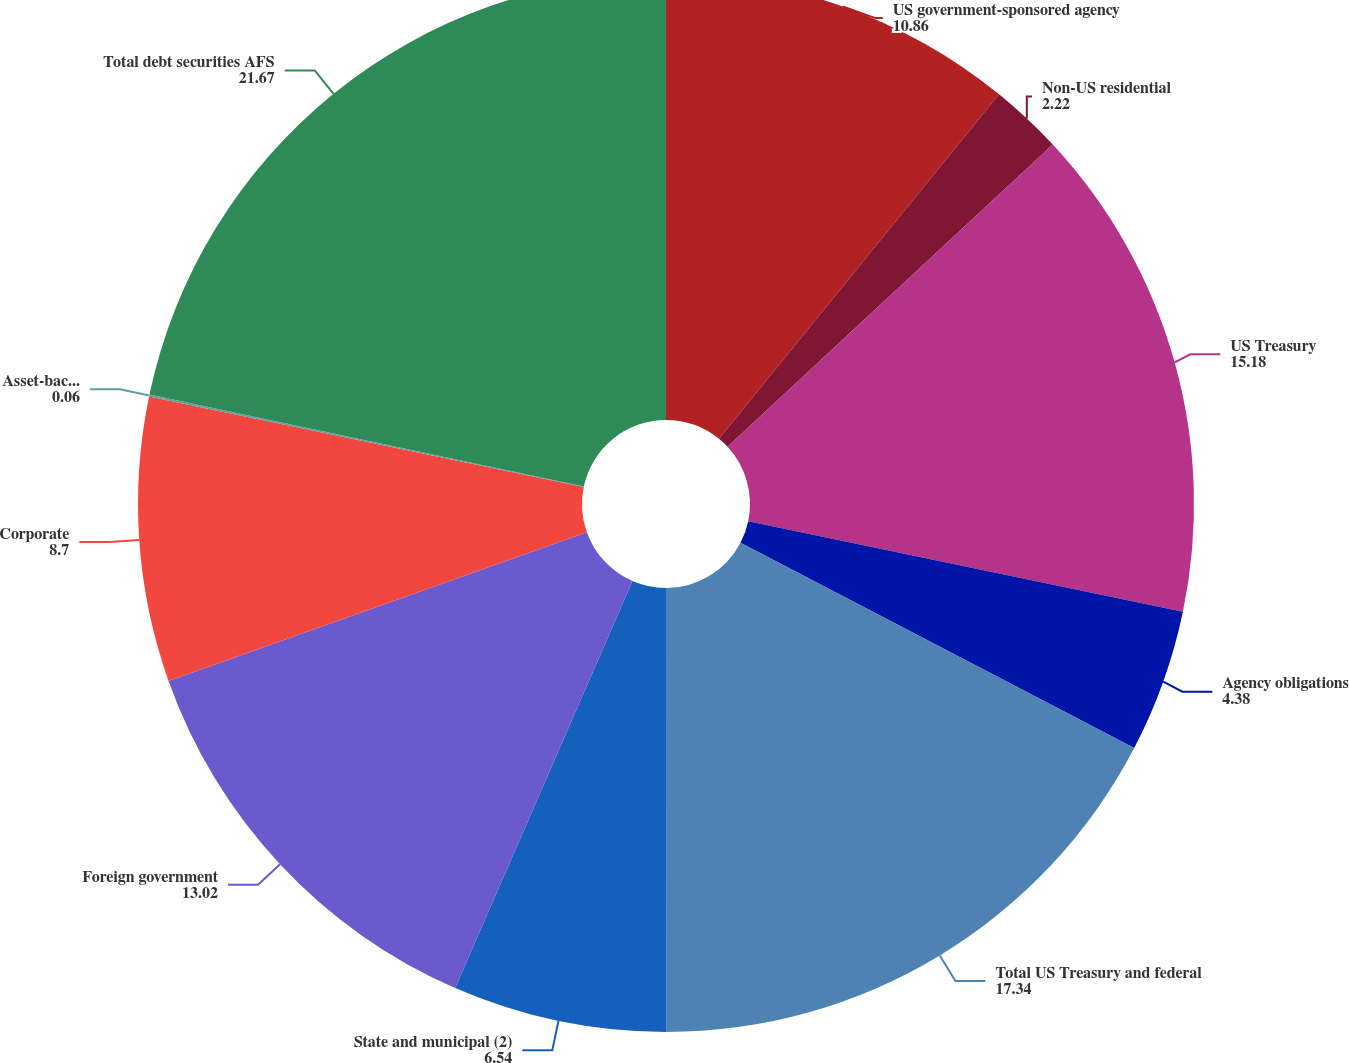<chart> <loc_0><loc_0><loc_500><loc_500><pie_chart><fcel>US government-sponsored agency<fcel>Non-US residential<fcel>US Treasury<fcel>Agency obligations<fcel>Total US Treasury and federal<fcel>State and municipal (2)<fcel>Foreign government<fcel>Corporate<fcel>Asset-backed securities (1)<fcel>Total debt securities AFS<nl><fcel>10.86%<fcel>2.22%<fcel>15.18%<fcel>4.38%<fcel>17.34%<fcel>6.54%<fcel>13.02%<fcel>8.7%<fcel>0.06%<fcel>21.67%<nl></chart> 